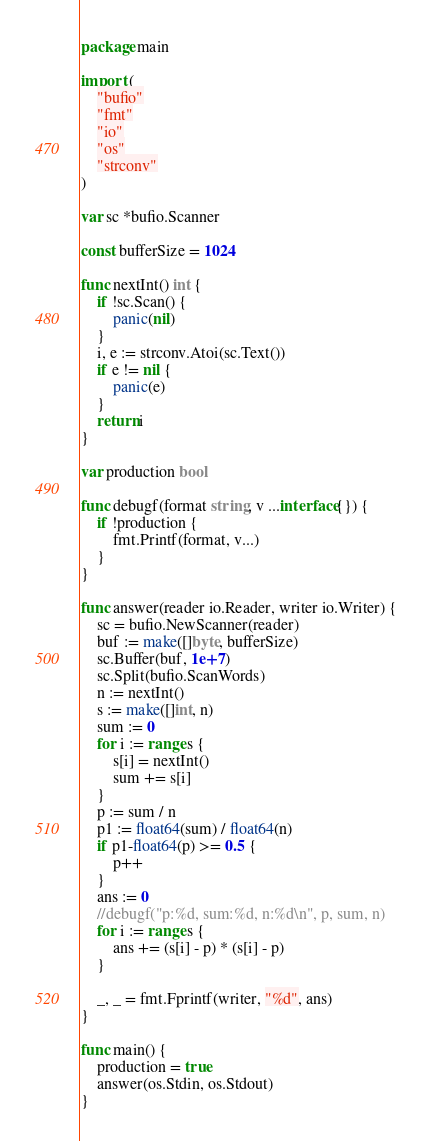Convert code to text. <code><loc_0><loc_0><loc_500><loc_500><_Go_>package main

import (
	"bufio"
	"fmt"
	"io"
	"os"
	"strconv"
)

var sc *bufio.Scanner

const bufferSize = 1024

func nextInt() int {
	if !sc.Scan() {
		panic(nil)
	}
	i, e := strconv.Atoi(sc.Text())
	if e != nil {
		panic(e)
	}
	return i
}

var production bool

func debugf(format string, v ...interface{}) {
	if !production {
		fmt.Printf(format, v...)
	}
}

func answer(reader io.Reader, writer io.Writer) {
	sc = bufio.NewScanner(reader)
	buf := make([]byte, bufferSize)
	sc.Buffer(buf, 1e+7)
	sc.Split(bufio.ScanWords)
	n := nextInt()
	s := make([]int, n)
	sum := 0
	for i := range s {
		s[i] = nextInt()
		sum += s[i]
	}
	p := sum / n
	p1 := float64(sum) / float64(n)
	if p1-float64(p) >= 0.5 {
		p++
	}
	ans := 0
	//debugf("p:%d, sum:%d, n:%d\n", p, sum, n)
	for i := range s {
		ans += (s[i] - p) * (s[i] - p)
	}

	_, _ = fmt.Fprintf(writer, "%d", ans)
}

func main() {
	production = true
	answer(os.Stdin, os.Stdout)
}
</code> 